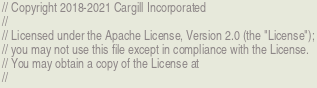<code> <loc_0><loc_0><loc_500><loc_500><_Rust_>// Copyright 2018-2021 Cargill Incorporated
//
// Licensed under the Apache License, Version 2.0 (the "License");
// you may not use this file except in compliance with the License.
// You may obtain a copy of the License at
//</code> 